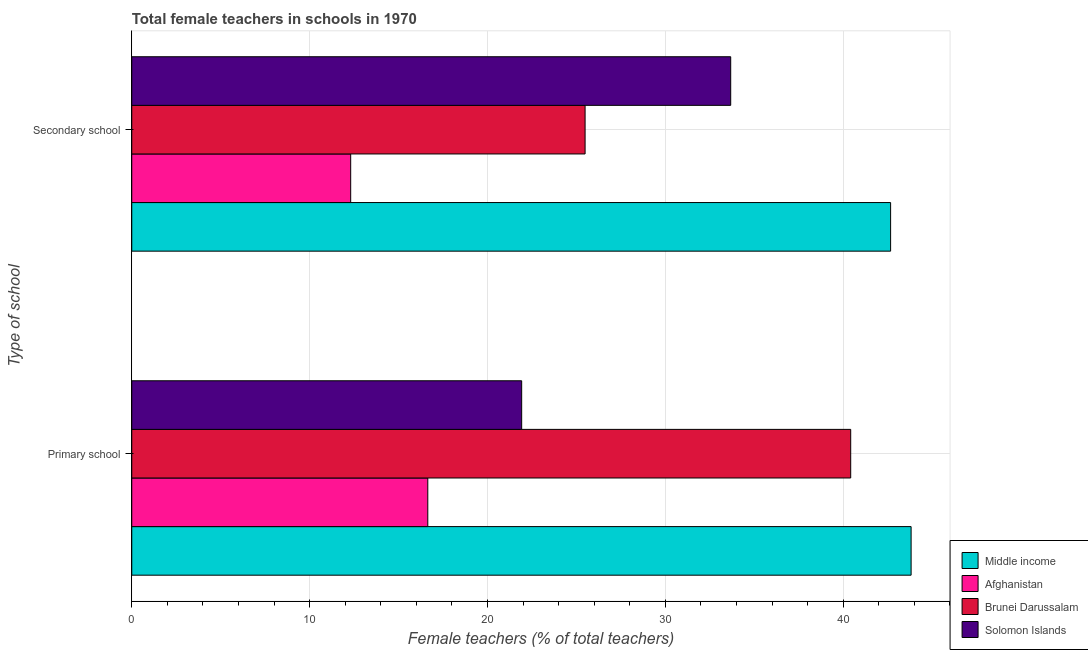Are the number of bars per tick equal to the number of legend labels?
Keep it short and to the point. Yes. How many bars are there on the 1st tick from the top?
Your answer should be very brief. 4. How many bars are there on the 2nd tick from the bottom?
Your answer should be very brief. 4. What is the label of the 2nd group of bars from the top?
Ensure brevity in your answer.  Primary school. What is the percentage of female teachers in primary schools in Solomon Islands?
Keep it short and to the point. 21.92. Across all countries, what is the maximum percentage of female teachers in primary schools?
Offer a terse response. 43.82. Across all countries, what is the minimum percentage of female teachers in secondary schools?
Offer a very short reply. 12.31. In which country was the percentage of female teachers in secondary schools maximum?
Give a very brief answer. Middle income. In which country was the percentage of female teachers in primary schools minimum?
Your answer should be compact. Afghanistan. What is the total percentage of female teachers in secondary schools in the graph?
Your answer should be very brief. 114.13. What is the difference between the percentage of female teachers in primary schools in Middle income and that in Solomon Islands?
Offer a very short reply. 21.89. What is the difference between the percentage of female teachers in primary schools in Middle income and the percentage of female teachers in secondary schools in Afghanistan?
Give a very brief answer. 31.51. What is the average percentage of female teachers in secondary schools per country?
Offer a very short reply. 28.53. What is the difference between the percentage of female teachers in secondary schools and percentage of female teachers in primary schools in Solomon Islands?
Offer a terse response. 11.75. What is the ratio of the percentage of female teachers in secondary schools in Solomon Islands to that in Afghanistan?
Ensure brevity in your answer.  2.74. Is the percentage of female teachers in primary schools in Brunei Darussalam less than that in Middle income?
Ensure brevity in your answer.  Yes. In how many countries, is the percentage of female teachers in secondary schools greater than the average percentage of female teachers in secondary schools taken over all countries?
Your answer should be compact. 2. What does the 1st bar from the top in Primary school represents?
Offer a terse response. Solomon Islands. What does the 3rd bar from the bottom in Primary school represents?
Your answer should be compact. Brunei Darussalam. Are all the bars in the graph horizontal?
Keep it short and to the point. Yes. What is the difference between two consecutive major ticks on the X-axis?
Your response must be concise. 10. How many legend labels are there?
Provide a short and direct response. 4. How are the legend labels stacked?
Your answer should be compact. Vertical. What is the title of the graph?
Your answer should be compact. Total female teachers in schools in 1970. What is the label or title of the X-axis?
Your answer should be compact. Female teachers (% of total teachers). What is the label or title of the Y-axis?
Ensure brevity in your answer.  Type of school. What is the Female teachers (% of total teachers) in Middle income in Primary school?
Give a very brief answer. 43.82. What is the Female teachers (% of total teachers) of Afghanistan in Primary school?
Provide a succinct answer. 16.64. What is the Female teachers (% of total teachers) of Brunei Darussalam in Primary school?
Offer a very short reply. 40.42. What is the Female teachers (% of total teachers) in Solomon Islands in Primary school?
Offer a very short reply. 21.92. What is the Female teachers (% of total teachers) of Middle income in Secondary school?
Provide a short and direct response. 42.66. What is the Female teachers (% of total teachers) in Afghanistan in Secondary school?
Your answer should be very brief. 12.31. What is the Female teachers (% of total teachers) in Brunei Darussalam in Secondary school?
Ensure brevity in your answer.  25.49. What is the Female teachers (% of total teachers) of Solomon Islands in Secondary school?
Your answer should be very brief. 33.67. Across all Type of school, what is the maximum Female teachers (% of total teachers) of Middle income?
Make the answer very short. 43.82. Across all Type of school, what is the maximum Female teachers (% of total teachers) in Afghanistan?
Keep it short and to the point. 16.64. Across all Type of school, what is the maximum Female teachers (% of total teachers) in Brunei Darussalam?
Keep it short and to the point. 40.42. Across all Type of school, what is the maximum Female teachers (% of total teachers) of Solomon Islands?
Keep it short and to the point. 33.67. Across all Type of school, what is the minimum Female teachers (% of total teachers) of Middle income?
Your response must be concise. 42.66. Across all Type of school, what is the minimum Female teachers (% of total teachers) of Afghanistan?
Keep it short and to the point. 12.31. Across all Type of school, what is the minimum Female teachers (% of total teachers) of Brunei Darussalam?
Your answer should be compact. 25.49. Across all Type of school, what is the minimum Female teachers (% of total teachers) in Solomon Islands?
Make the answer very short. 21.92. What is the total Female teachers (% of total teachers) of Middle income in the graph?
Make the answer very short. 86.48. What is the total Female teachers (% of total teachers) of Afghanistan in the graph?
Your answer should be very brief. 28.95. What is the total Female teachers (% of total teachers) of Brunei Darussalam in the graph?
Give a very brief answer. 65.91. What is the total Female teachers (% of total teachers) in Solomon Islands in the graph?
Your response must be concise. 55.59. What is the difference between the Female teachers (% of total teachers) of Middle income in Primary school and that in Secondary school?
Provide a succinct answer. 1.15. What is the difference between the Female teachers (% of total teachers) in Afghanistan in Primary school and that in Secondary school?
Offer a very short reply. 4.34. What is the difference between the Female teachers (% of total teachers) in Brunei Darussalam in Primary school and that in Secondary school?
Provide a succinct answer. 14.93. What is the difference between the Female teachers (% of total teachers) in Solomon Islands in Primary school and that in Secondary school?
Your answer should be very brief. -11.75. What is the difference between the Female teachers (% of total teachers) in Middle income in Primary school and the Female teachers (% of total teachers) in Afghanistan in Secondary school?
Your response must be concise. 31.51. What is the difference between the Female teachers (% of total teachers) of Middle income in Primary school and the Female teachers (% of total teachers) of Brunei Darussalam in Secondary school?
Provide a succinct answer. 18.33. What is the difference between the Female teachers (% of total teachers) in Middle income in Primary school and the Female teachers (% of total teachers) in Solomon Islands in Secondary school?
Your answer should be very brief. 10.14. What is the difference between the Female teachers (% of total teachers) in Afghanistan in Primary school and the Female teachers (% of total teachers) in Brunei Darussalam in Secondary school?
Offer a terse response. -8.84. What is the difference between the Female teachers (% of total teachers) of Afghanistan in Primary school and the Female teachers (% of total teachers) of Solomon Islands in Secondary school?
Your answer should be compact. -17.03. What is the difference between the Female teachers (% of total teachers) in Brunei Darussalam in Primary school and the Female teachers (% of total teachers) in Solomon Islands in Secondary school?
Offer a very short reply. 6.75. What is the average Female teachers (% of total teachers) in Middle income per Type of school?
Ensure brevity in your answer.  43.24. What is the average Female teachers (% of total teachers) in Afghanistan per Type of school?
Your answer should be compact. 14.48. What is the average Female teachers (% of total teachers) in Brunei Darussalam per Type of school?
Offer a very short reply. 32.95. What is the average Female teachers (% of total teachers) in Solomon Islands per Type of school?
Keep it short and to the point. 27.8. What is the difference between the Female teachers (% of total teachers) in Middle income and Female teachers (% of total teachers) in Afghanistan in Primary school?
Offer a terse response. 27.17. What is the difference between the Female teachers (% of total teachers) in Middle income and Female teachers (% of total teachers) in Brunei Darussalam in Primary school?
Offer a terse response. 3.4. What is the difference between the Female teachers (% of total teachers) in Middle income and Female teachers (% of total teachers) in Solomon Islands in Primary school?
Provide a succinct answer. 21.89. What is the difference between the Female teachers (% of total teachers) in Afghanistan and Female teachers (% of total teachers) in Brunei Darussalam in Primary school?
Ensure brevity in your answer.  -23.78. What is the difference between the Female teachers (% of total teachers) in Afghanistan and Female teachers (% of total teachers) in Solomon Islands in Primary school?
Keep it short and to the point. -5.28. What is the difference between the Female teachers (% of total teachers) of Brunei Darussalam and Female teachers (% of total teachers) of Solomon Islands in Primary school?
Give a very brief answer. 18.5. What is the difference between the Female teachers (% of total teachers) in Middle income and Female teachers (% of total teachers) in Afghanistan in Secondary school?
Keep it short and to the point. 30.35. What is the difference between the Female teachers (% of total teachers) of Middle income and Female teachers (% of total teachers) of Brunei Darussalam in Secondary school?
Provide a short and direct response. 17.18. What is the difference between the Female teachers (% of total teachers) of Middle income and Female teachers (% of total teachers) of Solomon Islands in Secondary school?
Keep it short and to the point. 8.99. What is the difference between the Female teachers (% of total teachers) in Afghanistan and Female teachers (% of total teachers) in Brunei Darussalam in Secondary school?
Ensure brevity in your answer.  -13.18. What is the difference between the Female teachers (% of total teachers) in Afghanistan and Female teachers (% of total teachers) in Solomon Islands in Secondary school?
Give a very brief answer. -21.37. What is the difference between the Female teachers (% of total teachers) in Brunei Darussalam and Female teachers (% of total teachers) in Solomon Islands in Secondary school?
Your response must be concise. -8.19. What is the ratio of the Female teachers (% of total teachers) of Middle income in Primary school to that in Secondary school?
Your answer should be very brief. 1.03. What is the ratio of the Female teachers (% of total teachers) of Afghanistan in Primary school to that in Secondary school?
Keep it short and to the point. 1.35. What is the ratio of the Female teachers (% of total teachers) in Brunei Darussalam in Primary school to that in Secondary school?
Offer a terse response. 1.59. What is the ratio of the Female teachers (% of total teachers) in Solomon Islands in Primary school to that in Secondary school?
Keep it short and to the point. 0.65. What is the difference between the highest and the second highest Female teachers (% of total teachers) in Middle income?
Your answer should be compact. 1.15. What is the difference between the highest and the second highest Female teachers (% of total teachers) in Afghanistan?
Offer a terse response. 4.34. What is the difference between the highest and the second highest Female teachers (% of total teachers) in Brunei Darussalam?
Provide a short and direct response. 14.93. What is the difference between the highest and the second highest Female teachers (% of total teachers) of Solomon Islands?
Your response must be concise. 11.75. What is the difference between the highest and the lowest Female teachers (% of total teachers) of Middle income?
Your response must be concise. 1.15. What is the difference between the highest and the lowest Female teachers (% of total teachers) in Afghanistan?
Your response must be concise. 4.34. What is the difference between the highest and the lowest Female teachers (% of total teachers) of Brunei Darussalam?
Offer a very short reply. 14.93. What is the difference between the highest and the lowest Female teachers (% of total teachers) of Solomon Islands?
Ensure brevity in your answer.  11.75. 